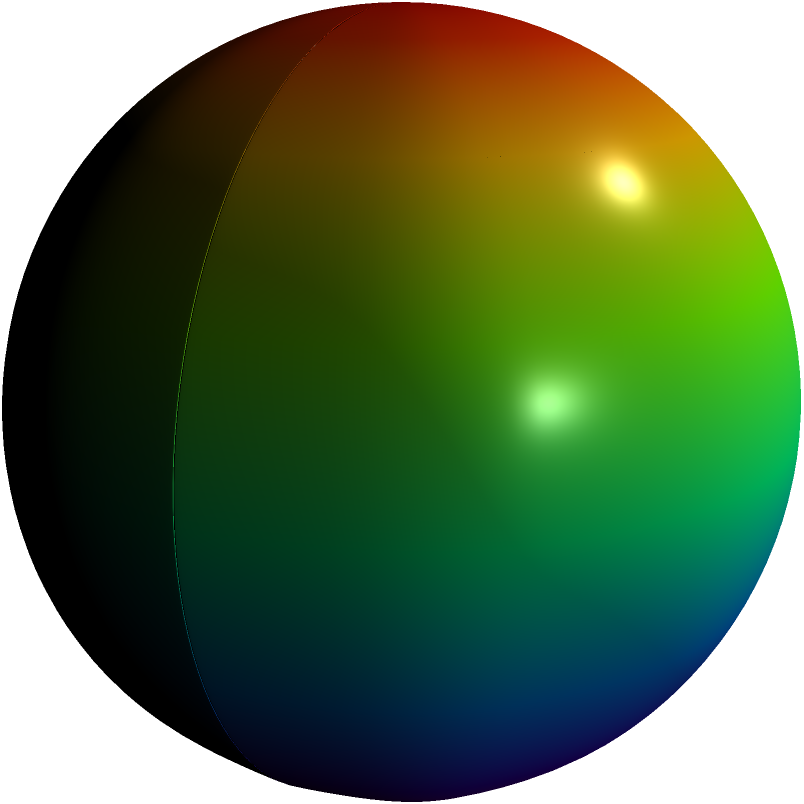Consider the spherical harmonic function $Y_2^1(\theta,\phi)$ represented by the colored surface in the image. Which of the following symmetry operations does this orbital exhibit?

a) Inversion symmetry
b) Mirror symmetry in the xy-plane
c) 4-fold rotational symmetry about the z-axis
d) 2-fold rotational symmetry about the z-axis To determine the symmetry of the molecular orbital represented by $Y_2^1(\theta,\phi)$, we need to analyze its behavior under different symmetry operations:

1. Inversion symmetry: 
   $Y_2^1(\pi-\theta,\phi+\pi) = -Y_2^1(\theta,\phi)$
   The orbital changes sign under inversion, so it does not have inversion symmetry.

2. Mirror symmetry in the xy-plane:
   $Y_2^1(\pi-\theta,\phi) = -Y_2^1(\theta,\phi)$
   The orbital changes sign when reflected in the xy-plane, so it does not have this mirror symmetry.

3. 4-fold rotational symmetry about the z-axis:
   $Y_2^1(\theta,\phi+\frac{\pi}{2}) \neq Y_2^1(\theta,\phi)$
   The orbital does not remain unchanged under a 90-degree rotation, so it does not have 4-fold rotational symmetry.

4. 2-fold rotational symmetry about the z-axis:
   $Y_2^1(\theta,\phi+\pi) = -Y_2^1(\theta,\phi)$
   The orbital changes sign under a 180-degree rotation, which is equivalent to having 2-fold rotational symmetry.

Therefore, the $Y_2^1(\theta,\phi)$ orbital exhibits 2-fold rotational symmetry about the z-axis.
Answer: d) 2-fold rotational symmetry about the z-axis 